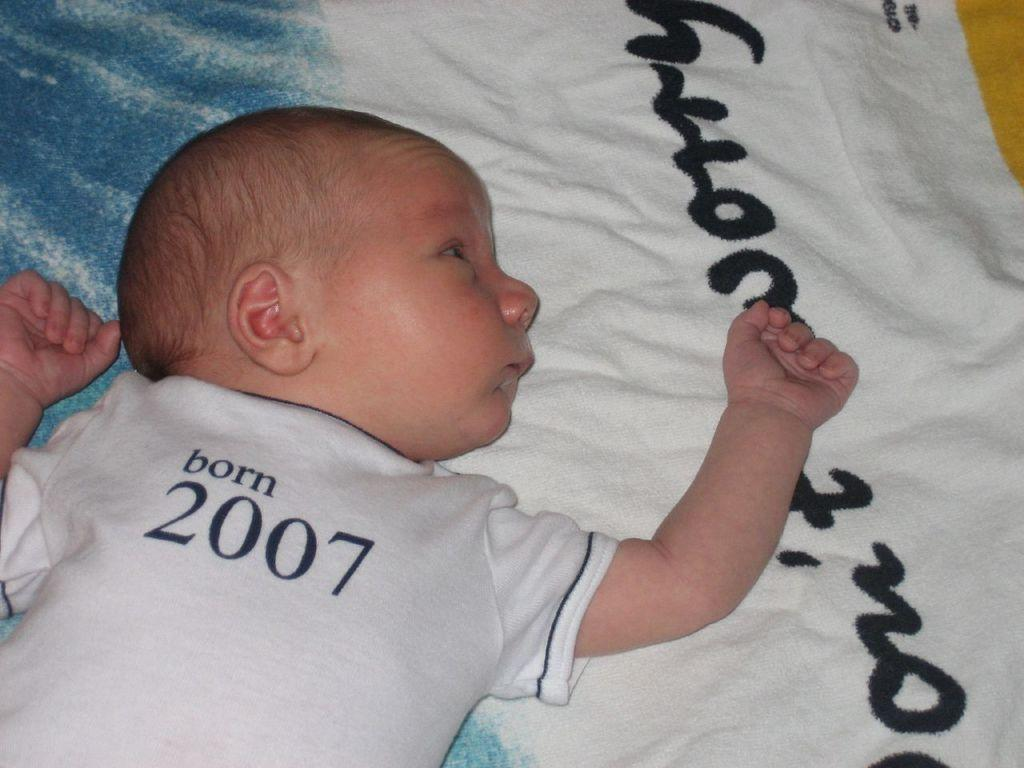What is the main subject of the picture? The main subject of the picture is a baby. Where is the baby located in the image? The baby is lying on a bed. What colors are present on the bed sheet in the image? The bed sheet is blue and white. What type of thunder can be heard in the background of the image? There is no audible sound, such as thunder, present in the image. The image is a still photograph, and it only shows visual information. 